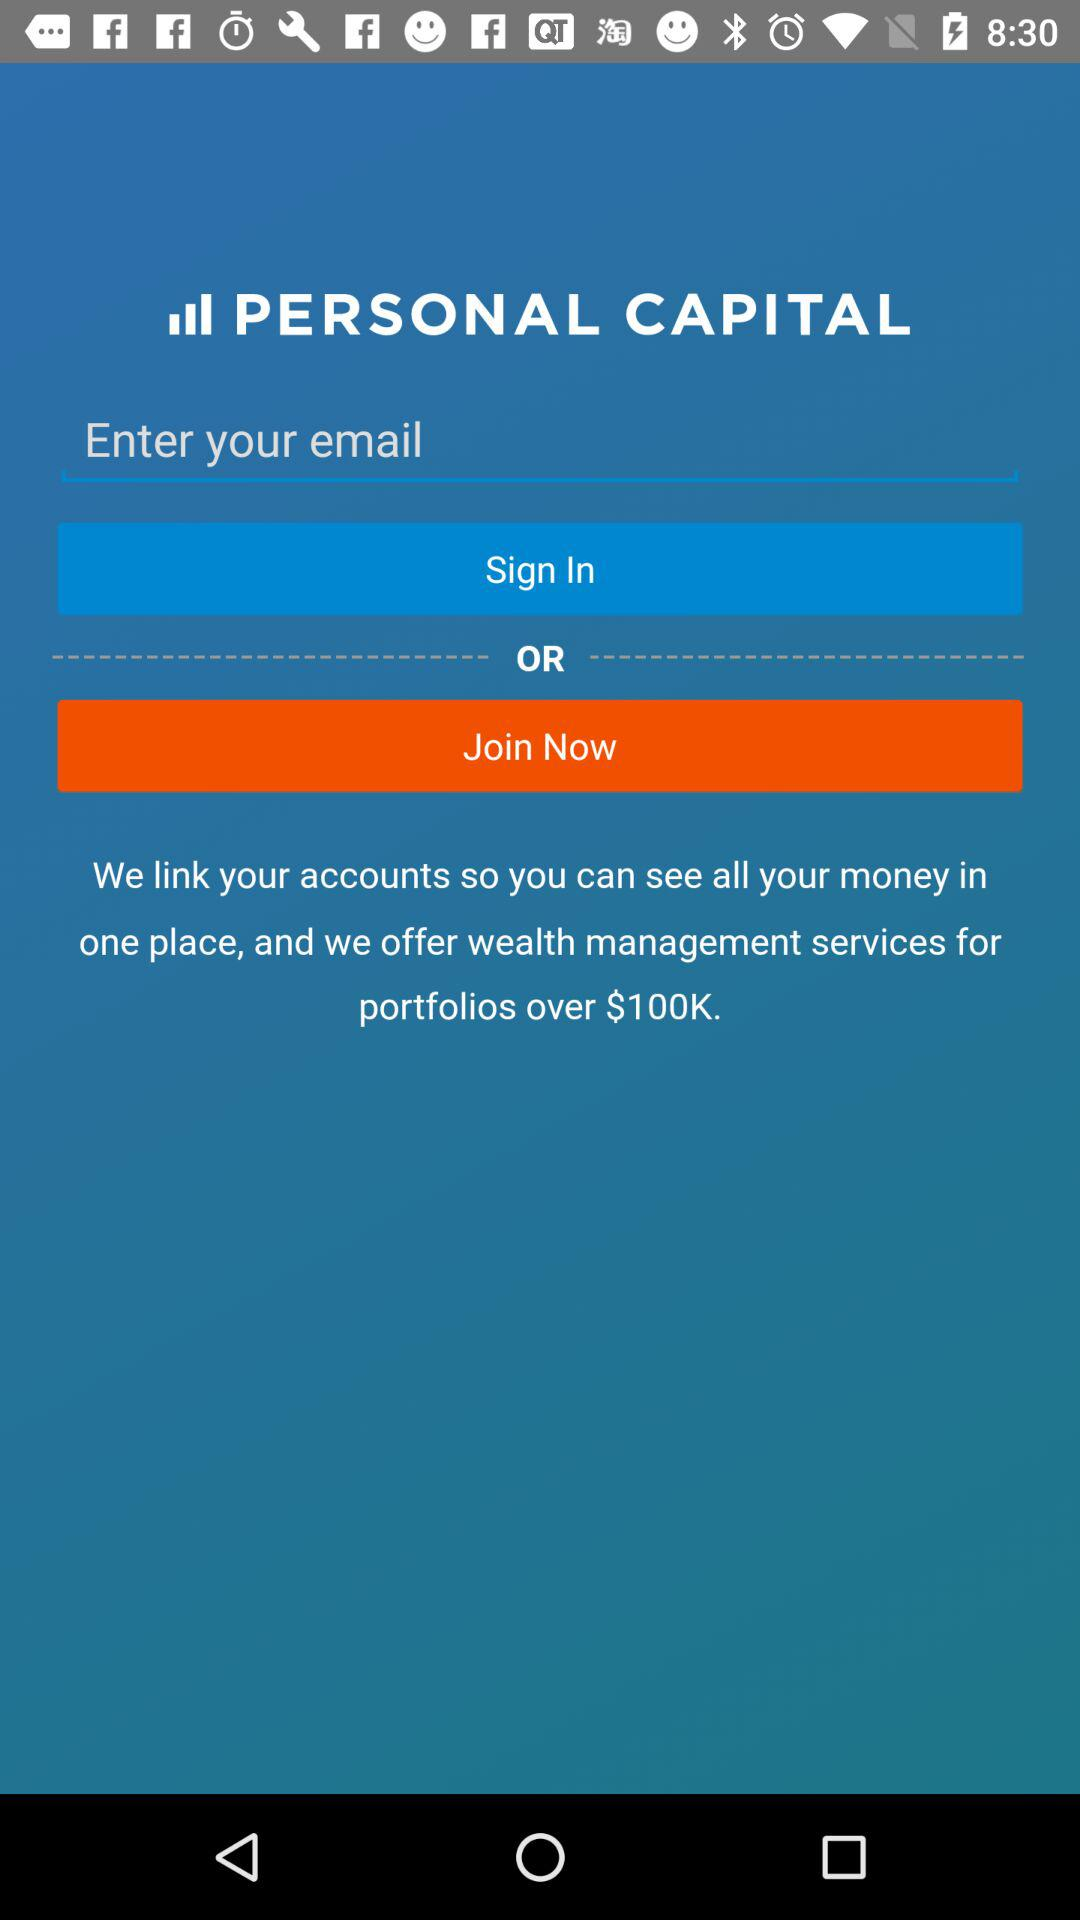What is the name of the application? The name of the application is "PERSONAL CAPITAL". 